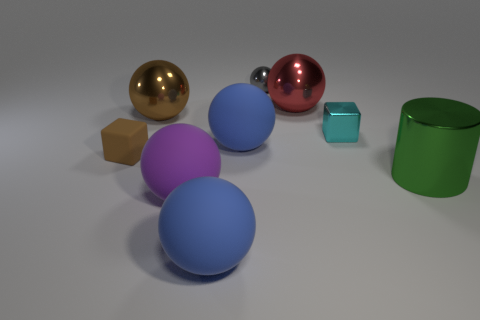There is a red thing; what shape is it?
Offer a very short reply. Sphere. Is the color of the tiny rubber thing the same as the shiny ball in front of the red thing?
Ensure brevity in your answer.  Yes. Are there any shiny objects that have the same color as the small rubber object?
Ensure brevity in your answer.  Yes. What is the color of the block on the left side of the large metal sphere to the right of the large blue sphere behind the purple matte sphere?
Provide a short and direct response. Brown. Does the large red thing have the same material as the small block that is on the right side of the big red metallic object?
Keep it short and to the point. Yes. What material is the purple thing?
Provide a succinct answer. Rubber. What material is the big object that is the same color as the matte cube?
Ensure brevity in your answer.  Metal. What number of other objects are there of the same material as the large cylinder?
Keep it short and to the point. 4. There is a object that is both right of the big red metal object and behind the large green metal cylinder; what is its shape?
Make the answer very short. Cube. There is a small cube that is made of the same material as the large cylinder; what is its color?
Your answer should be compact. Cyan. 